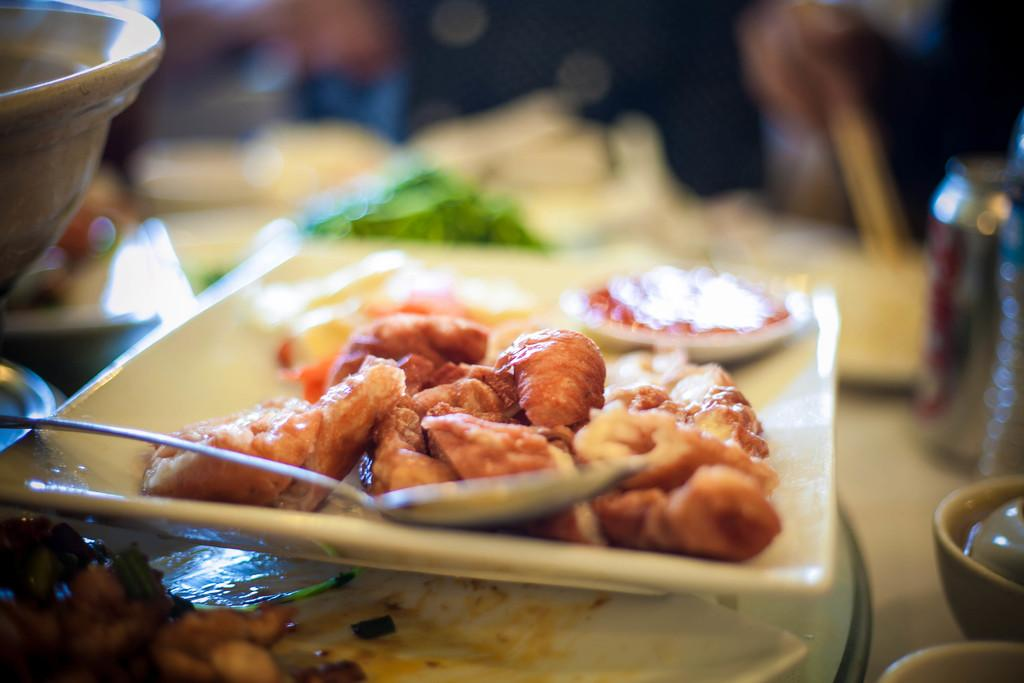What is on the plate that is visible in the image? There is food on a plate in the image. What utensil is on the plate in the image? There is a spoon on the plate in the image. Where is the plate located in the image? The plate is placed on a table in the image. What can be seen on the right side of the image? There are bowls and a tin on the right side of the image. What time does the record play on the clock in the image? There is no record or clock present in the image. Does the tin make any noise when struck by thunder in the image? There is no thunder or noise mentioned in the image; it only features a plate with food, a spoon, a table, bowls, and a tin. 